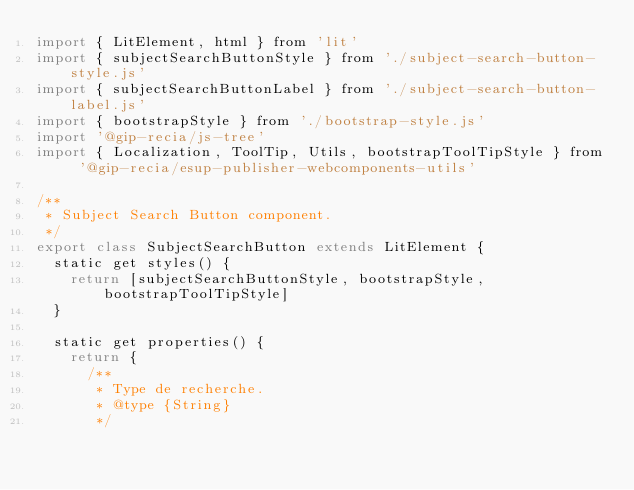Convert code to text. <code><loc_0><loc_0><loc_500><loc_500><_JavaScript_>import { LitElement, html } from 'lit'
import { subjectSearchButtonStyle } from './subject-search-button-style.js'
import { subjectSearchButtonLabel } from './subject-search-button-label.js'
import { bootstrapStyle } from './bootstrap-style.js'
import '@gip-recia/js-tree'
import { Localization, ToolTip, Utils, bootstrapToolTipStyle } from '@gip-recia/esup-publisher-webcomponents-utils'

/**
 * Subject Search Button component.
 */
export class SubjectSearchButton extends LitElement {
  static get styles() {
    return [subjectSearchButtonStyle, bootstrapStyle, bootstrapToolTipStyle]
  }

  static get properties() {
    return {
      /**
       * Type de recherche.
       * @type {String}
       */</code> 